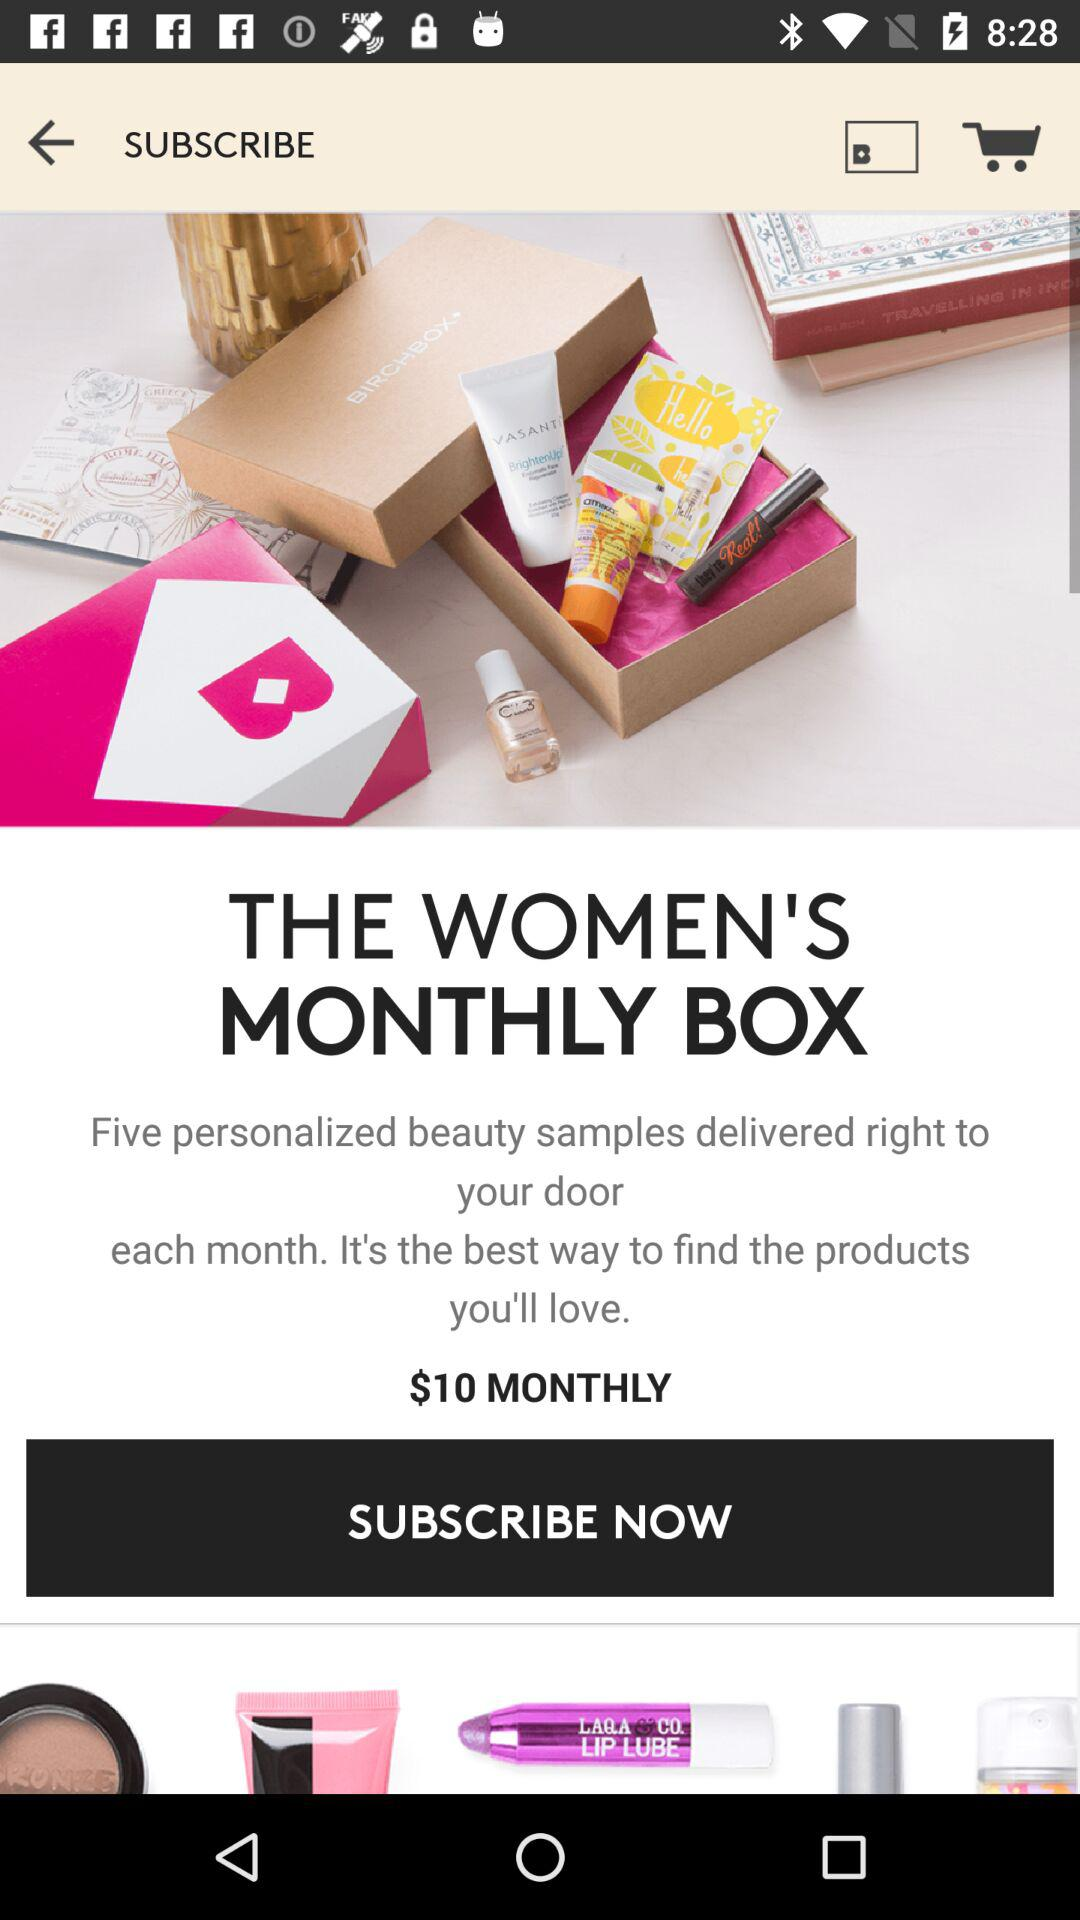How much is the monthly subscription fee?
Answer the question using a single word or phrase. $10 